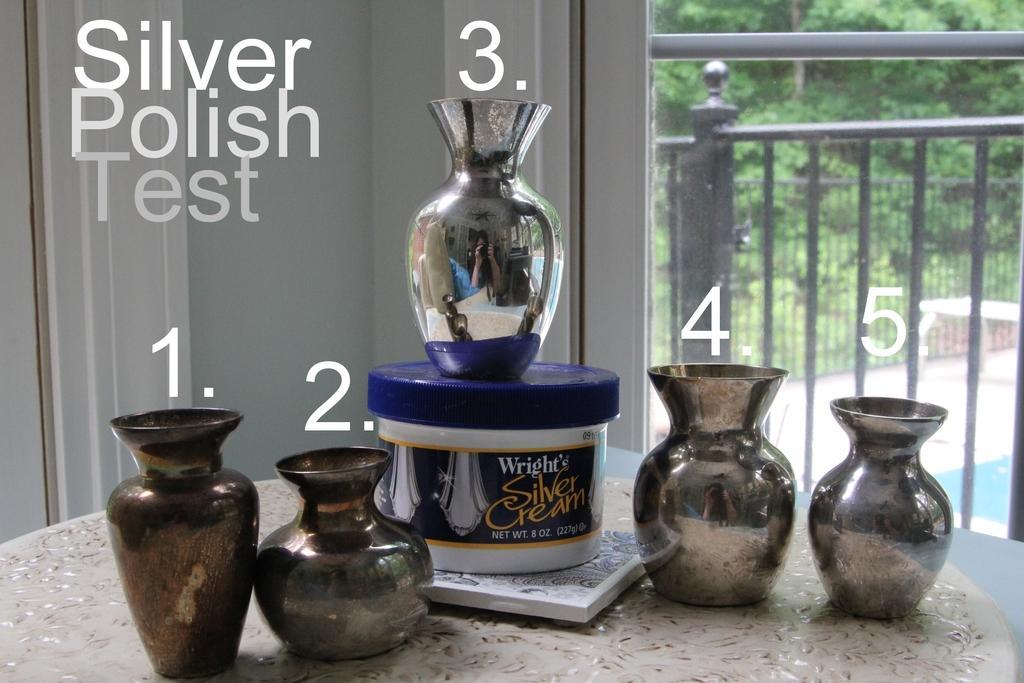Describe this image in one or two sentences. In this image I can see few vases. I can also see the box in white and blue color and the box is on the white color object. Background I can see the glass door and I can also see the railing and few trees in green color. 